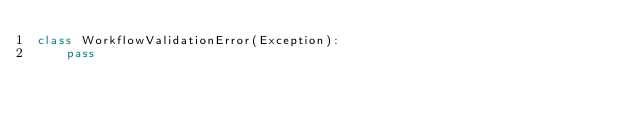Convert code to text. <code><loc_0><loc_0><loc_500><loc_500><_Python_>class WorkflowValidationError(Exception):
    pass
</code> 